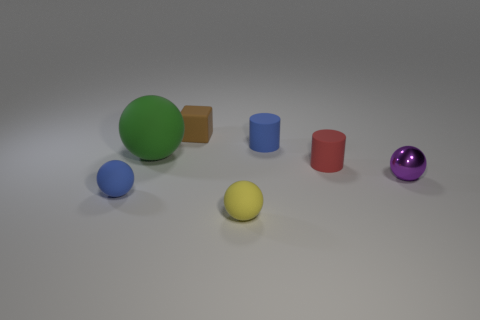Is there anything else that is the same size as the green thing?
Make the answer very short. No. What shape is the red thing that is the same size as the blue cylinder?
Your response must be concise. Cylinder. Is the material of the tiny blue sphere the same as the purple thing?
Give a very brief answer. No. How many metallic things are blue balls or spheres?
Keep it short and to the point. 1. There is a tiny thing in front of the small blue matte thing that is to the left of the tiny rubber block; what is its shape?
Offer a terse response. Sphere. What number of objects are blue rubber things right of the small blue sphere or small rubber objects that are in front of the tiny brown rubber object?
Provide a succinct answer. 4. What is the shape of the red thing that is the same material as the tiny yellow object?
Your answer should be very brief. Cylinder. There is another purple object that is the same shape as the large matte thing; what is it made of?
Keep it short and to the point. Metal. What number of other objects are there of the same size as the purple object?
Ensure brevity in your answer.  5. What is the material of the purple object?
Give a very brief answer. Metal. 